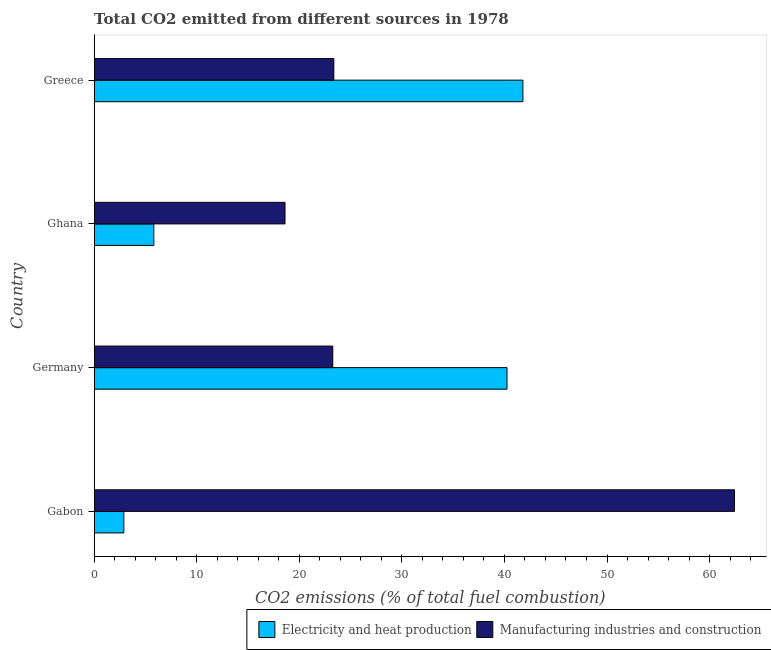How many different coloured bars are there?
Give a very brief answer. 2. How many groups of bars are there?
Your response must be concise. 4. Are the number of bars per tick equal to the number of legend labels?
Provide a succinct answer. Yes. How many bars are there on the 1st tick from the bottom?
Give a very brief answer. 2. What is the co2 emissions due to manufacturing industries in Germany?
Give a very brief answer. 23.26. Across all countries, what is the maximum co2 emissions due to electricity and heat production?
Provide a succinct answer. 41.8. Across all countries, what is the minimum co2 emissions due to manufacturing industries?
Offer a terse response. 18.6. In which country was the co2 emissions due to manufacturing industries maximum?
Provide a short and direct response. Gabon. In which country was the co2 emissions due to electricity and heat production minimum?
Offer a very short reply. Gabon. What is the total co2 emissions due to manufacturing industries in the graph?
Offer a terse response. 127.66. What is the difference between the co2 emissions due to manufacturing industries in Germany and that in Ghana?
Your answer should be very brief. 4.66. What is the difference between the co2 emissions due to electricity and heat production in Ghana and the co2 emissions due to manufacturing industries in Germany?
Provide a short and direct response. -17.45. What is the average co2 emissions due to electricity and heat production per country?
Keep it short and to the point. 22.69. What is the difference between the co2 emissions due to electricity and heat production and co2 emissions due to manufacturing industries in Greece?
Provide a short and direct response. 18.43. In how many countries, is the co2 emissions due to electricity and heat production greater than 10 %?
Give a very brief answer. 2. What is the ratio of the co2 emissions due to electricity and heat production in Germany to that in Ghana?
Ensure brevity in your answer.  6.92. Is the co2 emissions due to manufacturing industries in Gabon less than that in Greece?
Offer a very short reply. No. Is the difference between the co2 emissions due to manufacturing industries in Germany and Ghana greater than the difference between the co2 emissions due to electricity and heat production in Germany and Ghana?
Keep it short and to the point. No. What is the difference between the highest and the second highest co2 emissions due to electricity and heat production?
Make the answer very short. 1.55. What is the difference between the highest and the lowest co2 emissions due to electricity and heat production?
Give a very brief answer. 38.91. In how many countries, is the co2 emissions due to manufacturing industries greater than the average co2 emissions due to manufacturing industries taken over all countries?
Provide a succinct answer. 1. What does the 2nd bar from the top in Gabon represents?
Ensure brevity in your answer.  Electricity and heat production. What does the 1st bar from the bottom in Greece represents?
Provide a succinct answer. Electricity and heat production. How many bars are there?
Offer a terse response. 8. Are all the bars in the graph horizontal?
Keep it short and to the point. Yes. How many countries are there in the graph?
Keep it short and to the point. 4. How many legend labels are there?
Keep it short and to the point. 2. How are the legend labels stacked?
Your answer should be compact. Horizontal. What is the title of the graph?
Provide a short and direct response. Total CO2 emitted from different sources in 1978. What is the label or title of the X-axis?
Offer a terse response. CO2 emissions (% of total fuel combustion). What is the CO2 emissions (% of total fuel combustion) of Electricity and heat production in Gabon?
Keep it short and to the point. 2.89. What is the CO2 emissions (% of total fuel combustion) of Manufacturing industries and construction in Gabon?
Give a very brief answer. 62.43. What is the CO2 emissions (% of total fuel combustion) of Electricity and heat production in Germany?
Make the answer very short. 40.25. What is the CO2 emissions (% of total fuel combustion) in Manufacturing industries and construction in Germany?
Give a very brief answer. 23.26. What is the CO2 emissions (% of total fuel combustion) in Electricity and heat production in Ghana?
Provide a short and direct response. 5.81. What is the CO2 emissions (% of total fuel combustion) in Manufacturing industries and construction in Ghana?
Offer a terse response. 18.6. What is the CO2 emissions (% of total fuel combustion) of Electricity and heat production in Greece?
Offer a terse response. 41.8. What is the CO2 emissions (% of total fuel combustion) in Manufacturing industries and construction in Greece?
Ensure brevity in your answer.  23.36. Across all countries, what is the maximum CO2 emissions (% of total fuel combustion) of Electricity and heat production?
Your response must be concise. 41.8. Across all countries, what is the maximum CO2 emissions (% of total fuel combustion) in Manufacturing industries and construction?
Keep it short and to the point. 62.43. Across all countries, what is the minimum CO2 emissions (% of total fuel combustion) in Electricity and heat production?
Give a very brief answer. 2.89. Across all countries, what is the minimum CO2 emissions (% of total fuel combustion) of Manufacturing industries and construction?
Ensure brevity in your answer.  18.6. What is the total CO2 emissions (% of total fuel combustion) in Electricity and heat production in the graph?
Offer a terse response. 90.75. What is the total CO2 emissions (% of total fuel combustion) in Manufacturing industries and construction in the graph?
Your answer should be compact. 127.66. What is the difference between the CO2 emissions (% of total fuel combustion) in Electricity and heat production in Gabon and that in Germany?
Give a very brief answer. -37.36. What is the difference between the CO2 emissions (% of total fuel combustion) in Manufacturing industries and construction in Gabon and that in Germany?
Your response must be concise. 39.17. What is the difference between the CO2 emissions (% of total fuel combustion) of Electricity and heat production in Gabon and that in Ghana?
Your answer should be compact. -2.92. What is the difference between the CO2 emissions (% of total fuel combustion) of Manufacturing industries and construction in Gabon and that in Ghana?
Offer a very short reply. 43.82. What is the difference between the CO2 emissions (% of total fuel combustion) of Electricity and heat production in Gabon and that in Greece?
Give a very brief answer. -38.91. What is the difference between the CO2 emissions (% of total fuel combustion) in Manufacturing industries and construction in Gabon and that in Greece?
Provide a succinct answer. 39.06. What is the difference between the CO2 emissions (% of total fuel combustion) in Electricity and heat production in Germany and that in Ghana?
Your response must be concise. 34.44. What is the difference between the CO2 emissions (% of total fuel combustion) of Manufacturing industries and construction in Germany and that in Ghana?
Ensure brevity in your answer.  4.66. What is the difference between the CO2 emissions (% of total fuel combustion) in Electricity and heat production in Germany and that in Greece?
Make the answer very short. -1.55. What is the difference between the CO2 emissions (% of total fuel combustion) in Manufacturing industries and construction in Germany and that in Greece?
Provide a succinct answer. -0.1. What is the difference between the CO2 emissions (% of total fuel combustion) in Electricity and heat production in Ghana and that in Greece?
Ensure brevity in your answer.  -35.99. What is the difference between the CO2 emissions (% of total fuel combustion) in Manufacturing industries and construction in Ghana and that in Greece?
Your answer should be very brief. -4.76. What is the difference between the CO2 emissions (% of total fuel combustion) of Electricity and heat production in Gabon and the CO2 emissions (% of total fuel combustion) of Manufacturing industries and construction in Germany?
Offer a very short reply. -20.37. What is the difference between the CO2 emissions (% of total fuel combustion) of Electricity and heat production in Gabon and the CO2 emissions (% of total fuel combustion) of Manufacturing industries and construction in Ghana?
Provide a succinct answer. -15.71. What is the difference between the CO2 emissions (% of total fuel combustion) of Electricity and heat production in Gabon and the CO2 emissions (% of total fuel combustion) of Manufacturing industries and construction in Greece?
Offer a very short reply. -20.47. What is the difference between the CO2 emissions (% of total fuel combustion) in Electricity and heat production in Germany and the CO2 emissions (% of total fuel combustion) in Manufacturing industries and construction in Ghana?
Offer a terse response. 21.65. What is the difference between the CO2 emissions (% of total fuel combustion) in Electricity and heat production in Germany and the CO2 emissions (% of total fuel combustion) in Manufacturing industries and construction in Greece?
Make the answer very short. 16.89. What is the difference between the CO2 emissions (% of total fuel combustion) of Electricity and heat production in Ghana and the CO2 emissions (% of total fuel combustion) of Manufacturing industries and construction in Greece?
Your answer should be very brief. -17.55. What is the average CO2 emissions (% of total fuel combustion) in Electricity and heat production per country?
Ensure brevity in your answer.  22.69. What is the average CO2 emissions (% of total fuel combustion) of Manufacturing industries and construction per country?
Keep it short and to the point. 31.91. What is the difference between the CO2 emissions (% of total fuel combustion) of Electricity and heat production and CO2 emissions (% of total fuel combustion) of Manufacturing industries and construction in Gabon?
Your answer should be compact. -59.54. What is the difference between the CO2 emissions (% of total fuel combustion) in Electricity and heat production and CO2 emissions (% of total fuel combustion) in Manufacturing industries and construction in Germany?
Make the answer very short. 16.99. What is the difference between the CO2 emissions (% of total fuel combustion) in Electricity and heat production and CO2 emissions (% of total fuel combustion) in Manufacturing industries and construction in Ghana?
Provide a short and direct response. -12.79. What is the difference between the CO2 emissions (% of total fuel combustion) of Electricity and heat production and CO2 emissions (% of total fuel combustion) of Manufacturing industries and construction in Greece?
Give a very brief answer. 18.43. What is the ratio of the CO2 emissions (% of total fuel combustion) in Electricity and heat production in Gabon to that in Germany?
Offer a terse response. 0.07. What is the ratio of the CO2 emissions (% of total fuel combustion) of Manufacturing industries and construction in Gabon to that in Germany?
Offer a terse response. 2.68. What is the ratio of the CO2 emissions (% of total fuel combustion) in Electricity and heat production in Gabon to that in Ghana?
Your response must be concise. 0.5. What is the ratio of the CO2 emissions (% of total fuel combustion) in Manufacturing industries and construction in Gabon to that in Ghana?
Your answer should be very brief. 3.36. What is the ratio of the CO2 emissions (% of total fuel combustion) of Electricity and heat production in Gabon to that in Greece?
Your response must be concise. 0.07. What is the ratio of the CO2 emissions (% of total fuel combustion) in Manufacturing industries and construction in Gabon to that in Greece?
Give a very brief answer. 2.67. What is the ratio of the CO2 emissions (% of total fuel combustion) of Electricity and heat production in Germany to that in Ghana?
Make the answer very short. 6.92. What is the ratio of the CO2 emissions (% of total fuel combustion) of Manufacturing industries and construction in Germany to that in Ghana?
Offer a terse response. 1.25. What is the ratio of the CO2 emissions (% of total fuel combustion) of Electricity and heat production in Germany to that in Greece?
Provide a short and direct response. 0.96. What is the ratio of the CO2 emissions (% of total fuel combustion) in Electricity and heat production in Ghana to that in Greece?
Provide a short and direct response. 0.14. What is the ratio of the CO2 emissions (% of total fuel combustion) of Manufacturing industries and construction in Ghana to that in Greece?
Offer a very short reply. 0.8. What is the difference between the highest and the second highest CO2 emissions (% of total fuel combustion) in Electricity and heat production?
Your answer should be compact. 1.55. What is the difference between the highest and the second highest CO2 emissions (% of total fuel combustion) in Manufacturing industries and construction?
Your answer should be very brief. 39.06. What is the difference between the highest and the lowest CO2 emissions (% of total fuel combustion) in Electricity and heat production?
Make the answer very short. 38.91. What is the difference between the highest and the lowest CO2 emissions (% of total fuel combustion) in Manufacturing industries and construction?
Offer a very short reply. 43.82. 